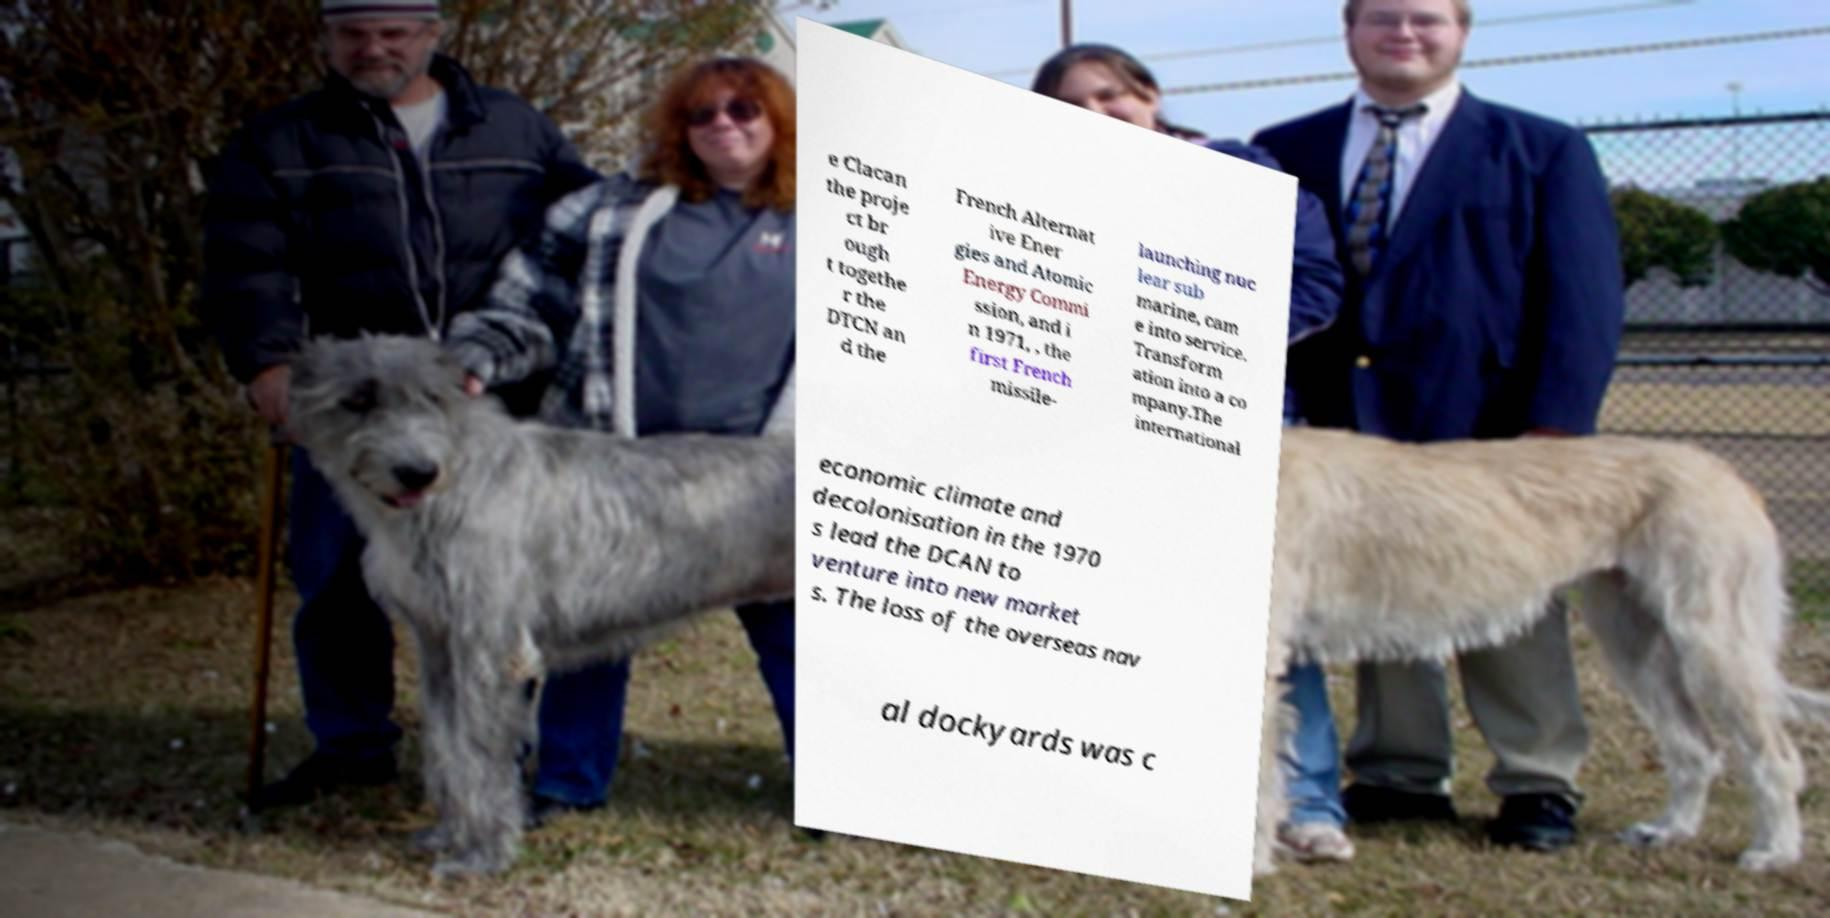What messages or text are displayed in this image? I need them in a readable, typed format. e Clacan the proje ct br ough t togethe r the DTCN an d the French Alternat ive Ener gies and Atomic Energy Commi ssion, and i n 1971, , the first French missile- launching nuc lear sub marine, cam e into service. Transform ation into a co mpany.The international economic climate and decolonisation in the 1970 s lead the DCAN to venture into new market s. The loss of the overseas nav al dockyards was c 